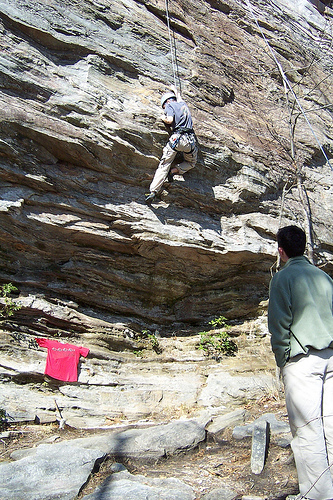<image>
Can you confirm if the shirt is on the wall? Yes. Looking at the image, I can see the shirt is positioned on top of the wall, with the wall providing support. 